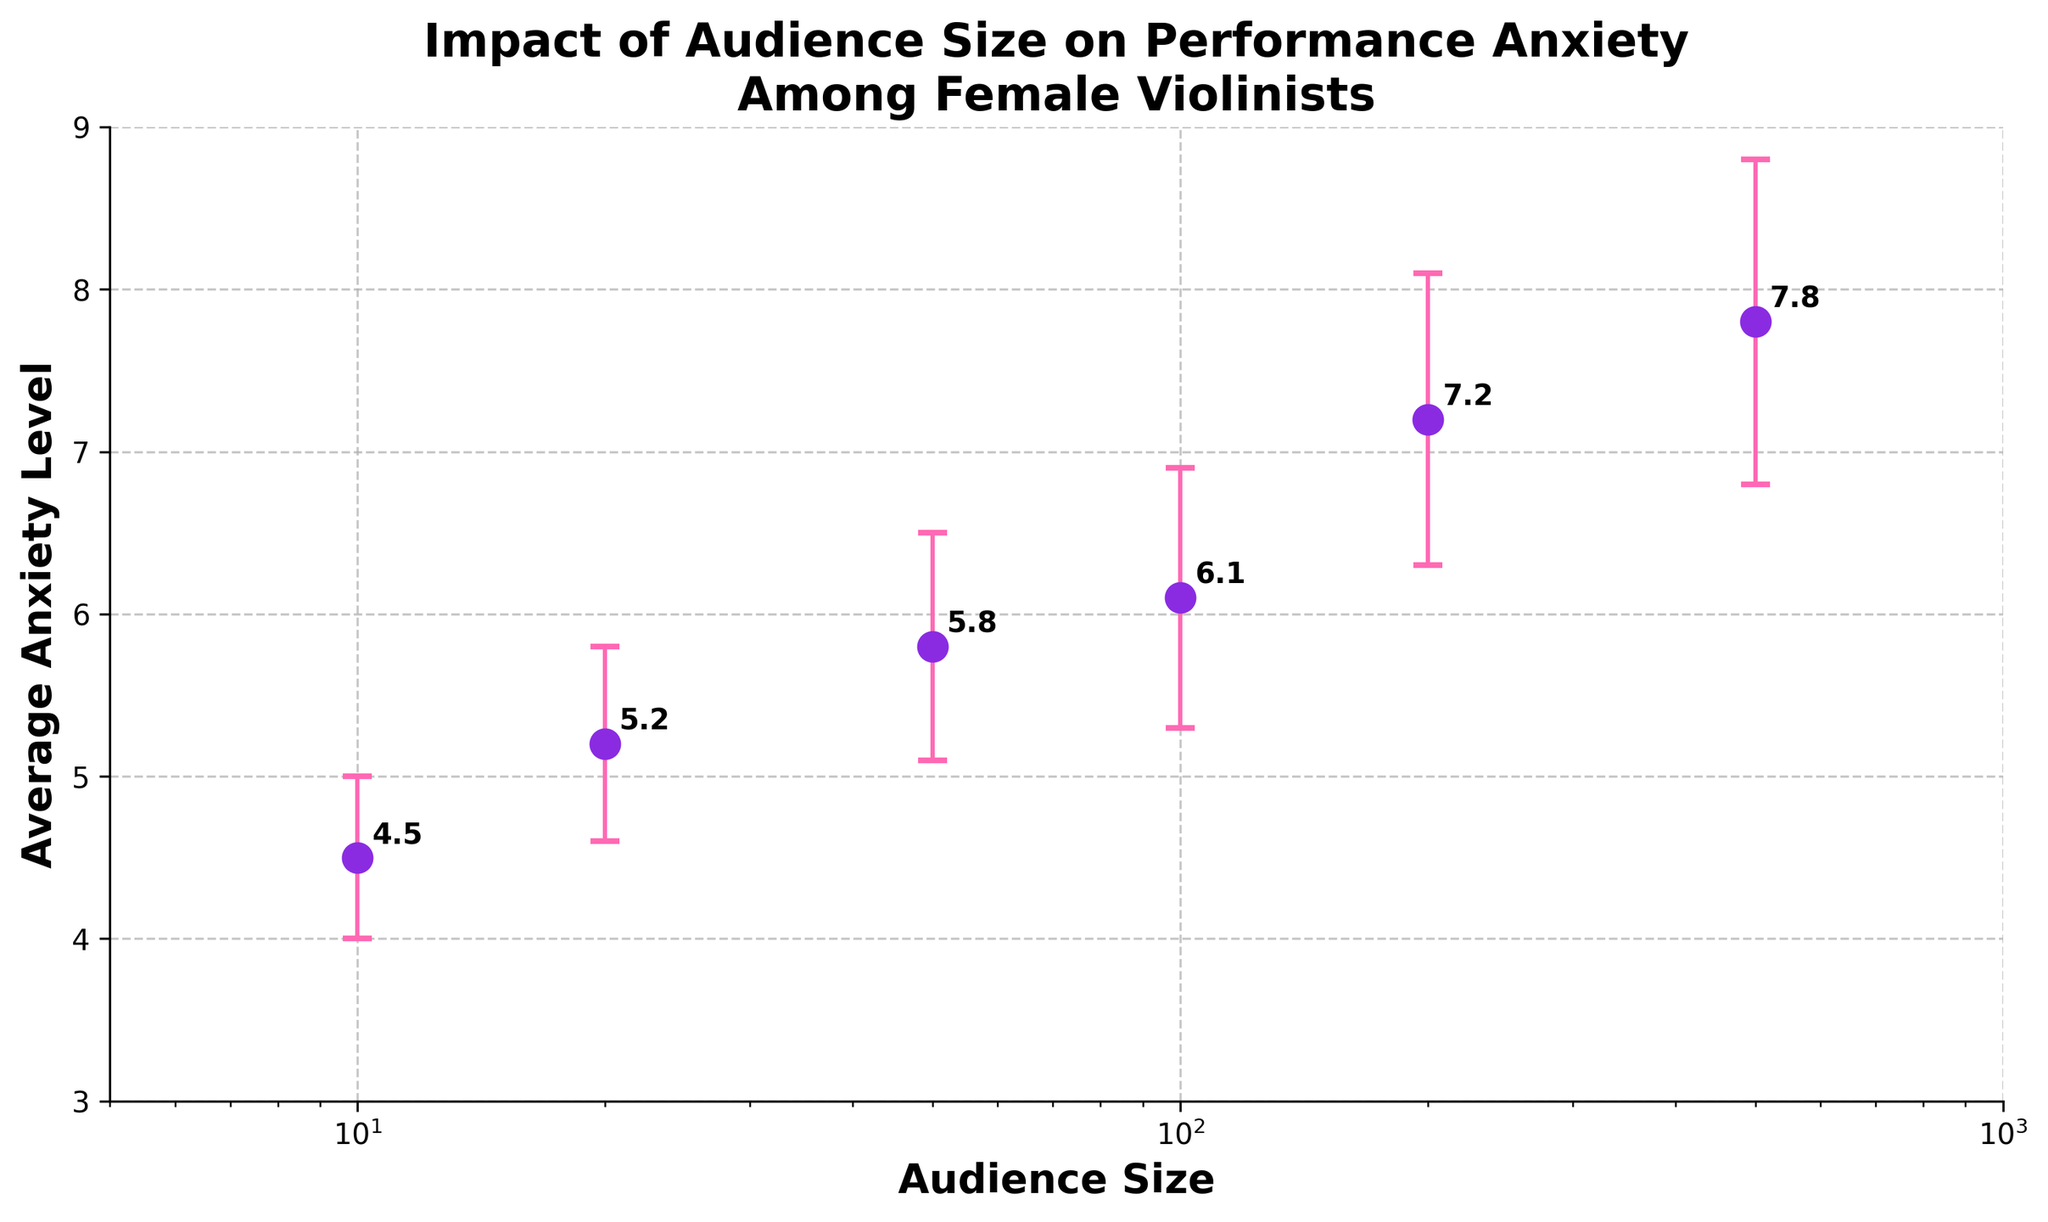What is the title of the figure? The title can be found at the top of the figure. The title is meant to summarize the content or purpose of the plot briefly.
Answer: Impact of Audience Size on Performance Anxiety Among Female Violinists What is the anxiety level when the audience size is 20? Locate the data point corresponding to an audience size of 20 on the x-axis, then follow upwards to the y-axis to read the anxiety level.
Answer: 5.2 What color are the error bars? Observe the visual properties of the error bars in the figure.
Answer: Pink Which audience size corresponds to the highest average anxiety level? Identify the data point with the highest position on the y-axis, then find the corresponding audience size on the x-axis.
Answer: 500 What are the y-axis limits of the figure? Inspect the numerical range along the y-axis from the bottom to the top of the figure.
Answer: 3 to 9 How does the average anxiety level change as the audience size increases from 10 to 500? Compare the y-values for audience sizes 10 and 500, noting the change from 4.5 to 7.8
Answer: It increases By how much does the average anxiety level increase when the audience size increases from 100 to 200? Find the y-values for audience sizes 100 and 200, then subtract the first from the second: 7.2 - 6.1
Answer: 1.1 What is the average anxiety level for an audience size of 50? Locate the data point for an audience size of 50 on the x-axis and read the corresponding anxiety level on the y-axis.
Answer: 5.8 Which audience sizes have an average anxiety level above 6.0? Identify the data points where the y-values are greater than 6.0, then find their corresponding x-values.
Answer: 100, 200, 500 What is the standard deviation of the anxiety level for an audience size of 500? Find the error bar length or the text annotation near the data point for an audience size of 500.
Answer: 1.0 